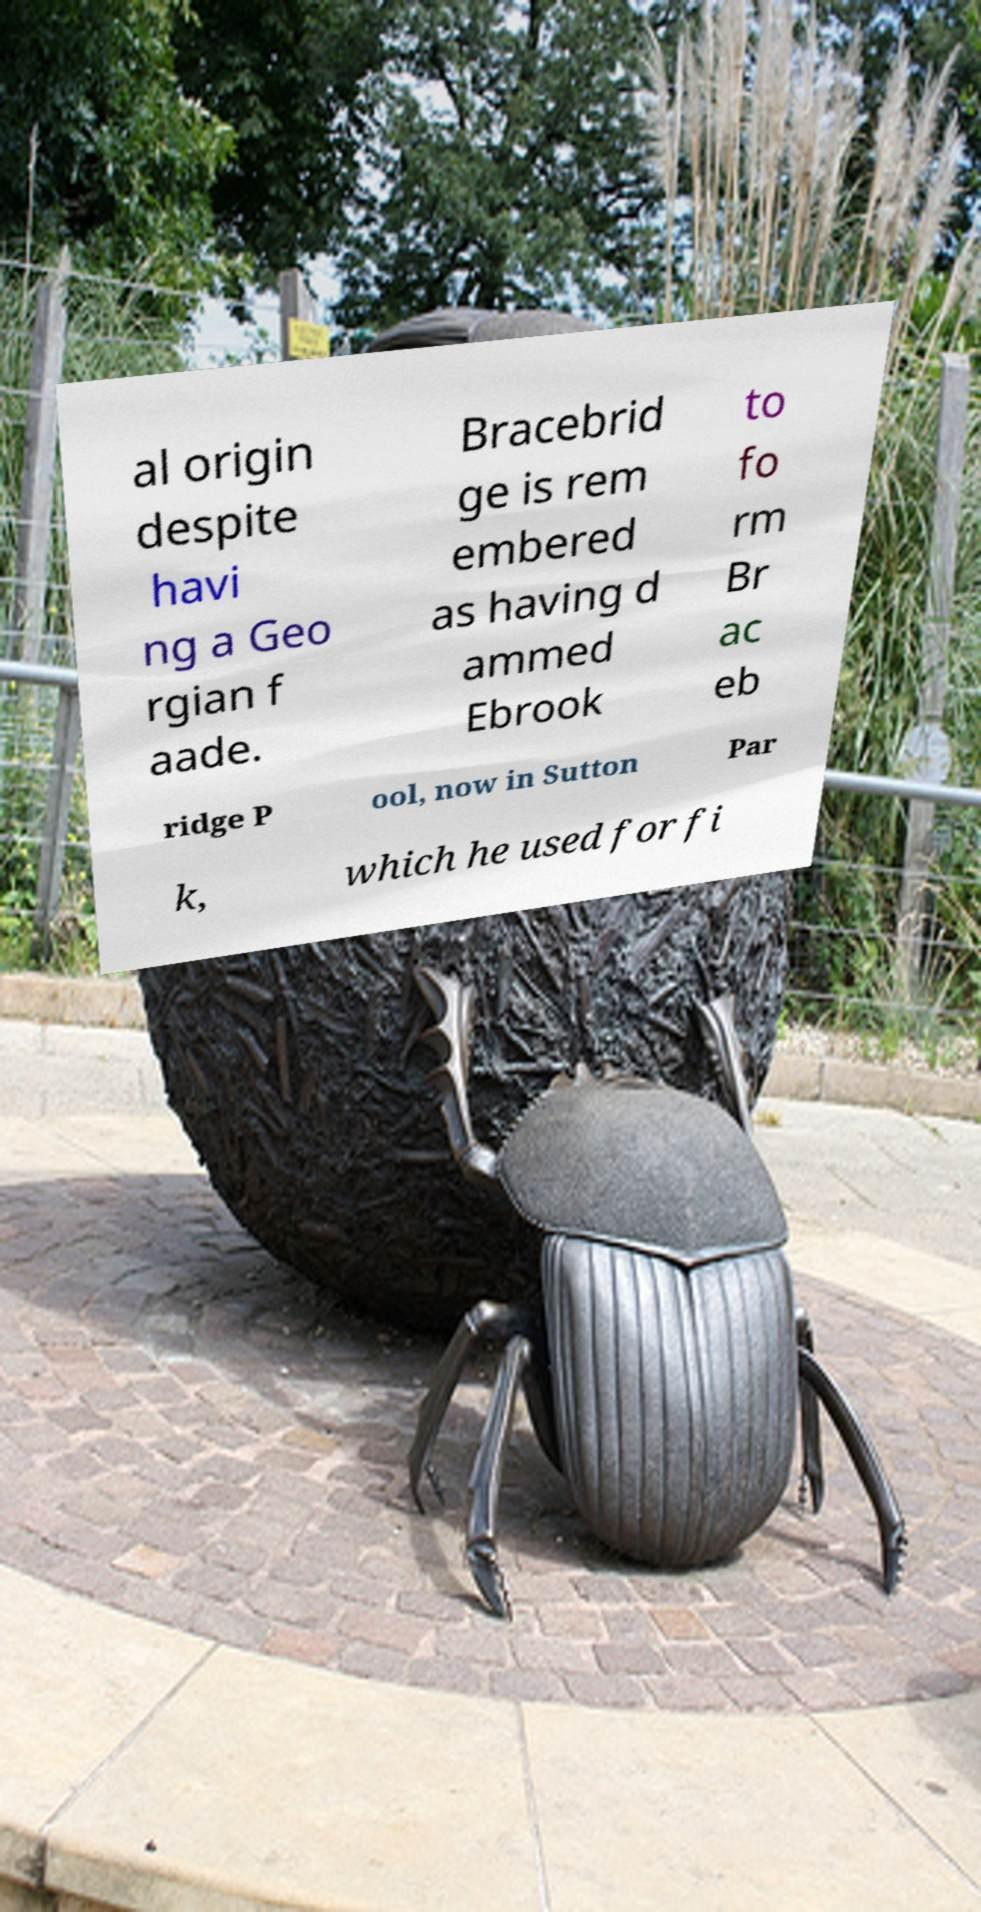I need the written content from this picture converted into text. Can you do that? al origin despite havi ng a Geo rgian f aade. Bracebrid ge is rem embered as having d ammed Ebrook to fo rm Br ac eb ridge P ool, now in Sutton Par k, which he used for fi 